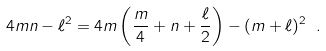Convert formula to latex. <formula><loc_0><loc_0><loc_500><loc_500>4 m n - \ell ^ { 2 } = 4 m \left ( \frac { m } { 4 } + n + \frac { \ell } { 2 } \right ) - ( m + \ell ) ^ { 2 } \ .</formula> 